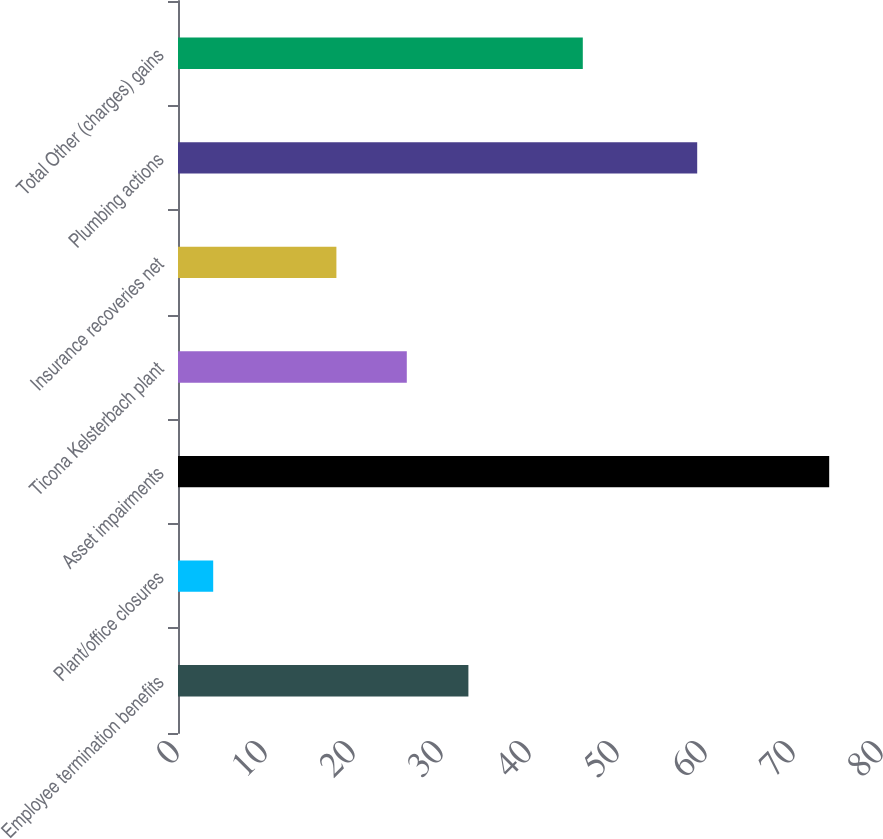<chart> <loc_0><loc_0><loc_500><loc_500><bar_chart><fcel>Employee termination benefits<fcel>Plant/office closures<fcel>Asset impairments<fcel>Ticona Kelsterbach plant<fcel>Insurance recoveries net<fcel>Plumbing actions<fcel>Total Other (charges) gains<nl><fcel>33<fcel>4<fcel>74<fcel>26<fcel>18<fcel>59<fcel>46<nl></chart> 